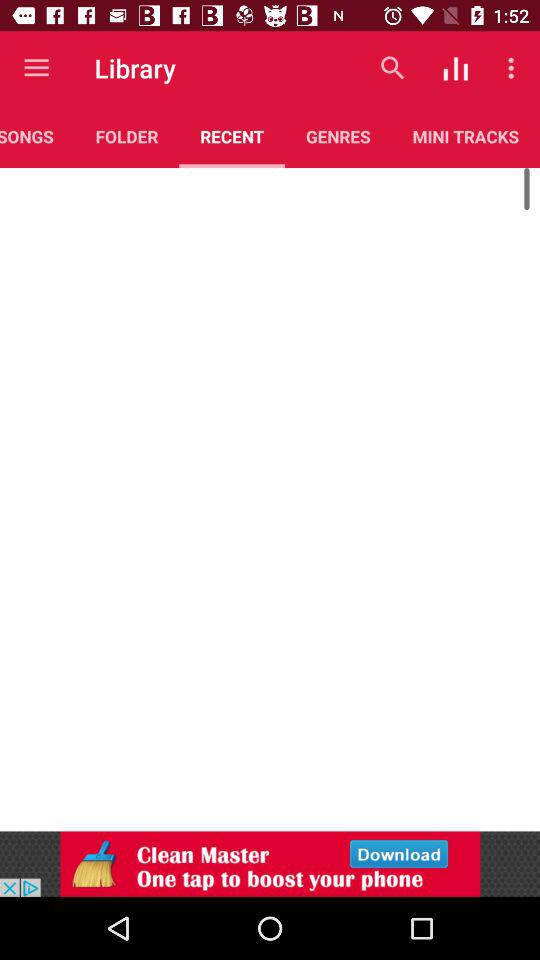Which tab is selected? The selected tab is "RECENT". 